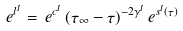<formula> <loc_0><loc_0><loc_500><loc_500>e ^ { l ^ { I } } = \, e ^ { c ^ { I } } \, ( \tau _ { \infty } - \tau ) ^ { - 2 \gamma ^ { I } } \, e ^ { s ^ { I } ( \tau ) }</formula> 